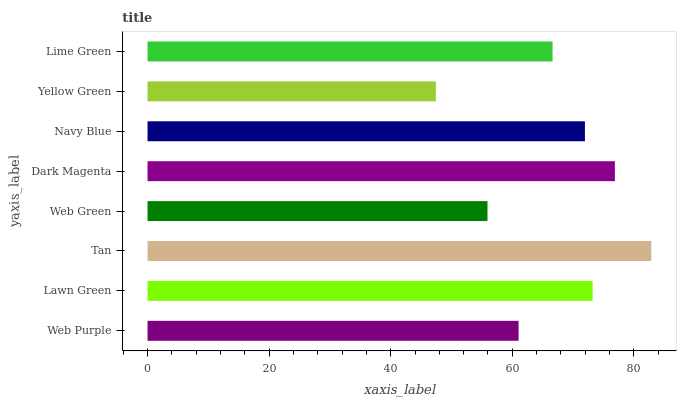Is Yellow Green the minimum?
Answer yes or no. Yes. Is Tan the maximum?
Answer yes or no. Yes. Is Lawn Green the minimum?
Answer yes or no. No. Is Lawn Green the maximum?
Answer yes or no. No. Is Lawn Green greater than Web Purple?
Answer yes or no. Yes. Is Web Purple less than Lawn Green?
Answer yes or no. Yes. Is Web Purple greater than Lawn Green?
Answer yes or no. No. Is Lawn Green less than Web Purple?
Answer yes or no. No. Is Navy Blue the high median?
Answer yes or no. Yes. Is Lime Green the low median?
Answer yes or no. Yes. Is Lime Green the high median?
Answer yes or no. No. Is Yellow Green the low median?
Answer yes or no. No. 